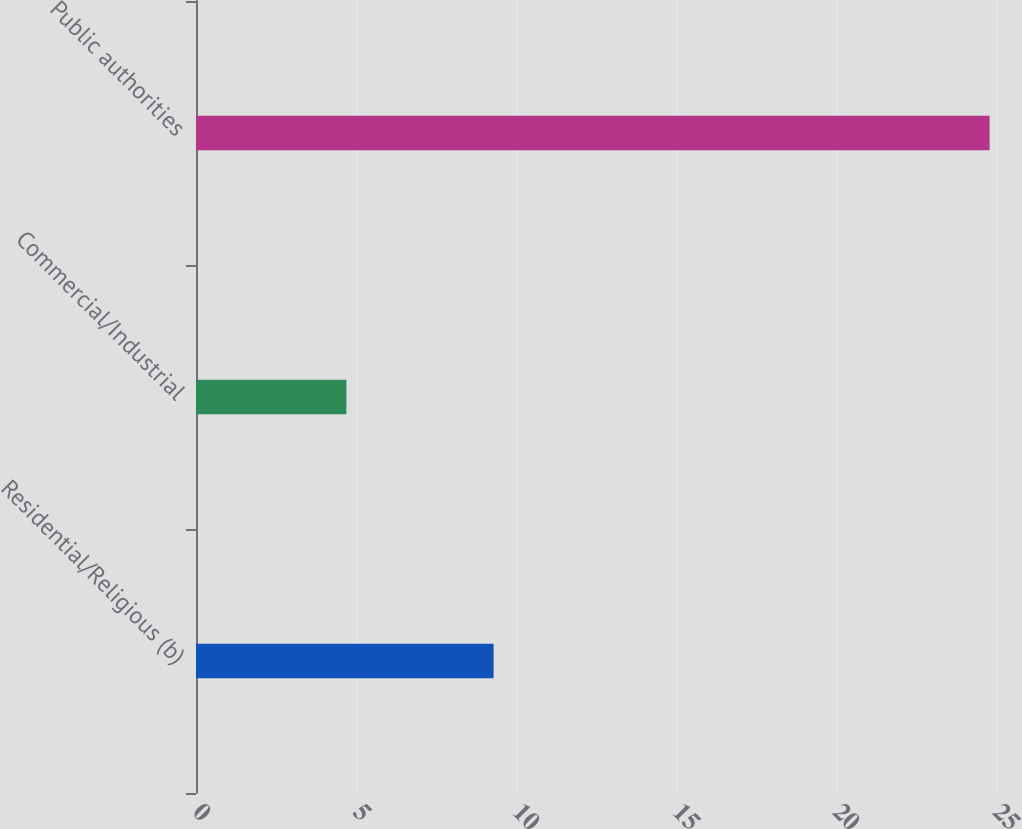Convert chart to OTSL. <chart><loc_0><loc_0><loc_500><loc_500><bar_chart><fcel>Residential/Religious (b)<fcel>Commercial/Industrial<fcel>Public authorities<nl><fcel>9.3<fcel>4.7<fcel>24.8<nl></chart> 